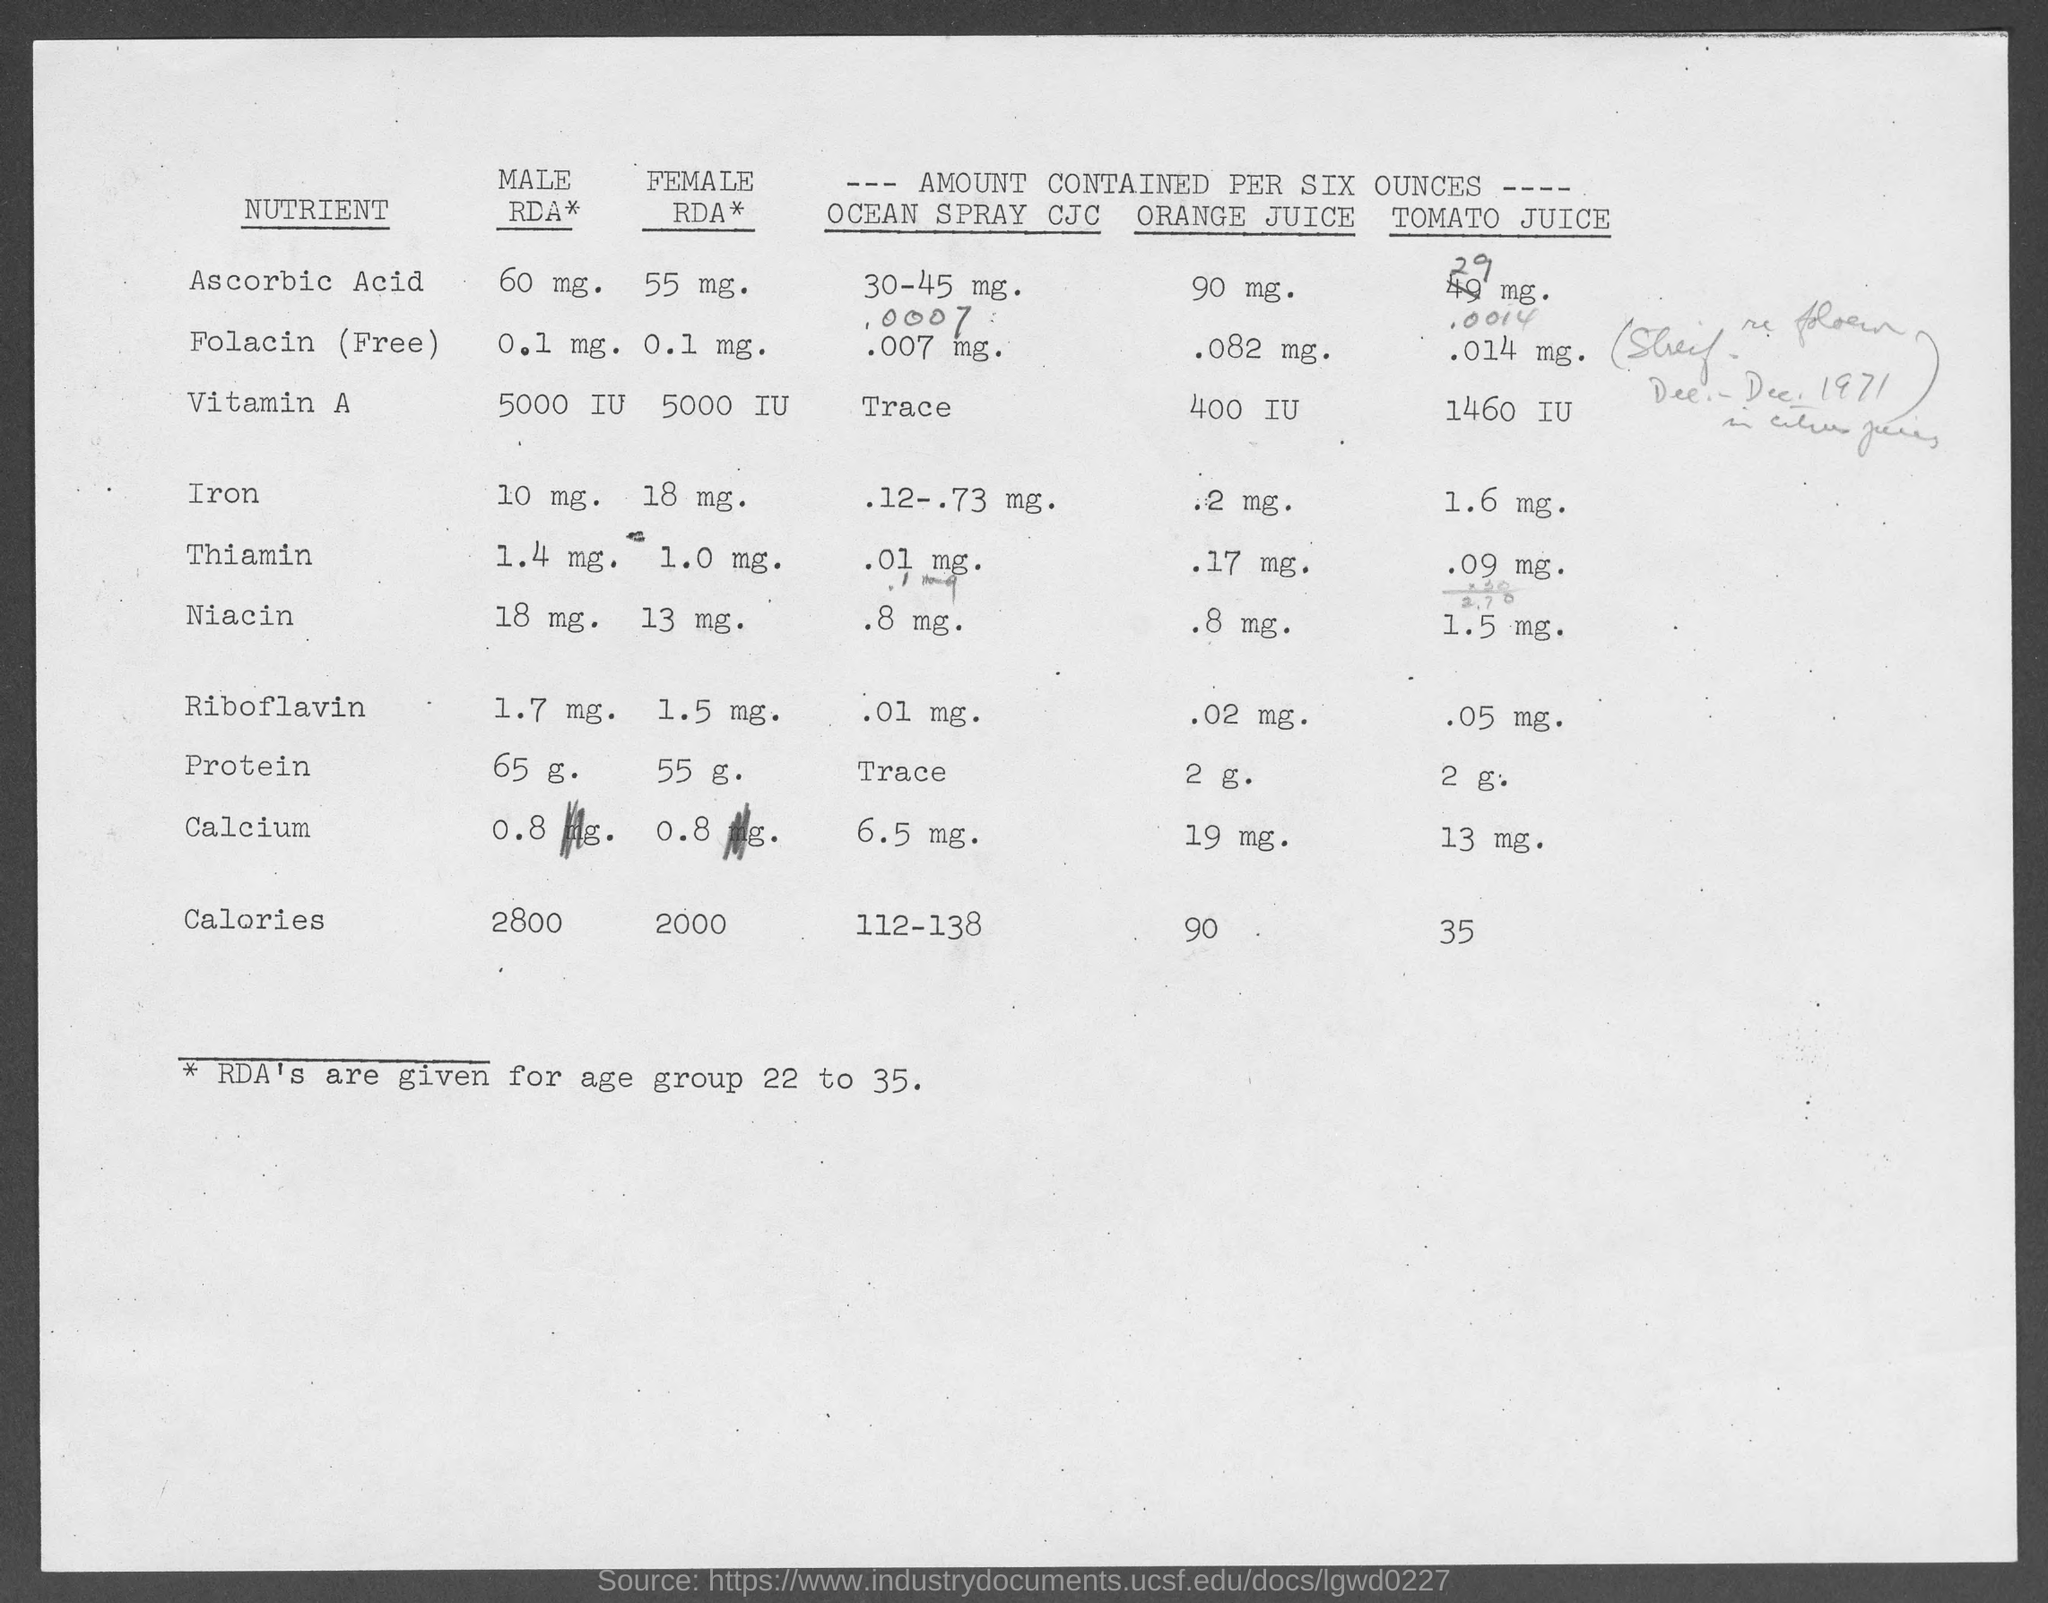Mention a couple of crucial points in this snapshot. The recommended daily allowance (RDA) for iron in men is 10 milligrams. The recommended daily allowance for protein consumption in males is 65 grams per day. The recommended daily amount of riboflavin for males is 1.7 milligrams. The recommended daily allowance for men for folic acid (in its free form) is 0.1 milligrams. The recommended daily allowance (RDA) for calcium for males is 0.8 milligrams per day. 